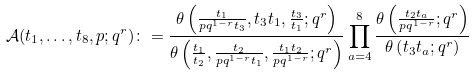<formula> <loc_0><loc_0><loc_500><loc_500>\mathcal { A } ( t _ { 1 } , \dots , t _ { 8 } , p ; q ^ { r } ) \colon = \frac { \theta \left ( \frac { t _ { 1 } } { p q ^ { 1 - r } t _ { 3 } } , t _ { 3 } t _ { 1 } , \frac { t _ { 3 } } { t _ { 1 } } ; q ^ { r } \right ) } { \theta \left ( \frac { t _ { 1 } } { t _ { 2 } } , \frac { t _ { 2 } } { p q ^ { 1 - r } t _ { 1 } } , \frac { t _ { 1 } t _ { 2 } } { p q ^ { 1 - r } } ; q ^ { r } \right ) } \prod _ { a = 4 } ^ { 8 } \frac { \theta \left ( \frac { t _ { 2 } t _ { a } } { p q ^ { 1 - r } } ; q ^ { r } \right ) } { \theta \left ( t _ { 3 } t _ { a } ; q ^ { r } \right ) }</formula> 